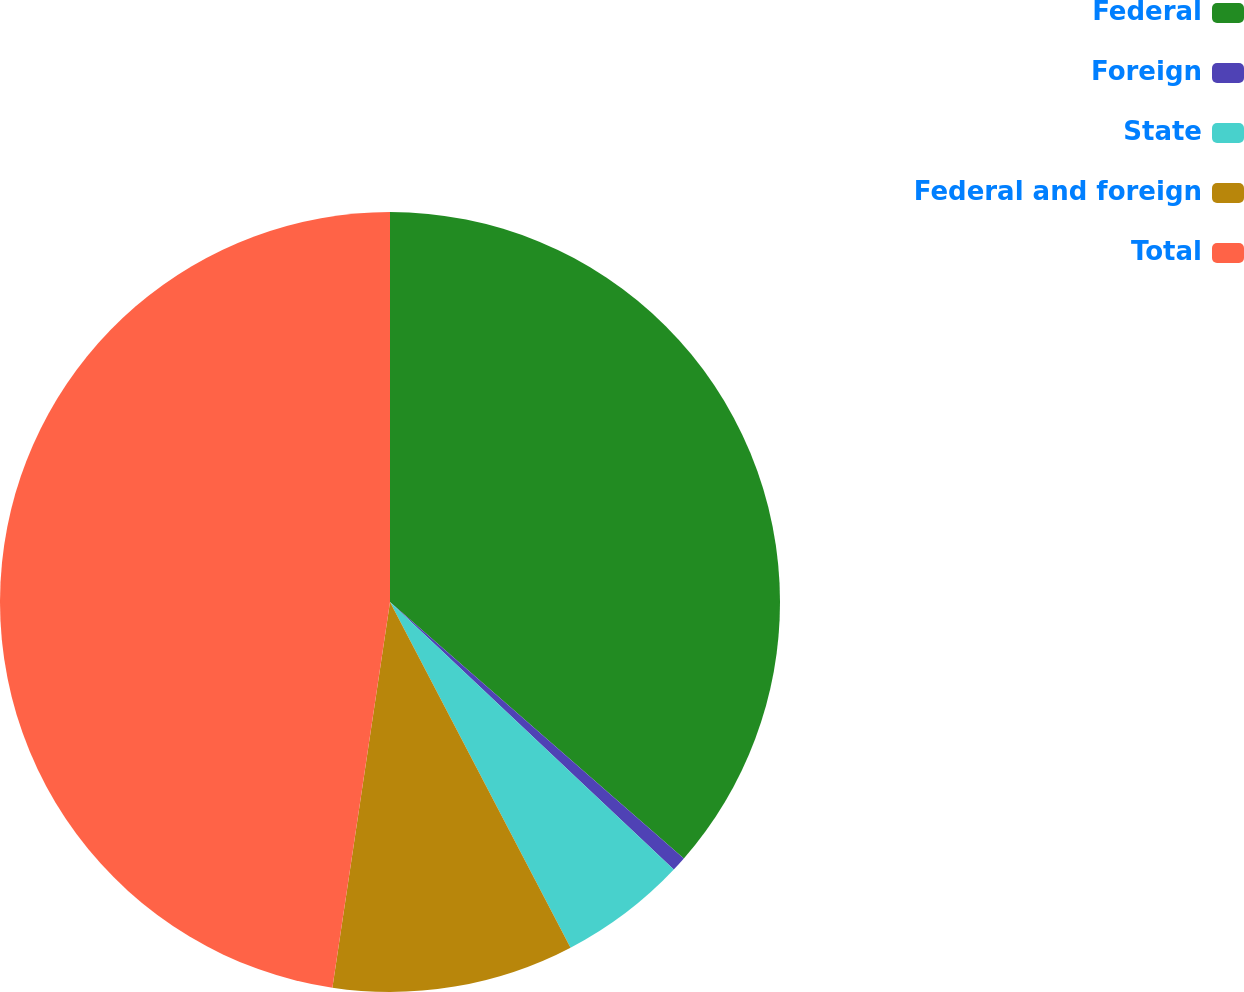<chart> <loc_0><loc_0><loc_500><loc_500><pie_chart><fcel>Federal<fcel>Foreign<fcel>State<fcel>Federal and foreign<fcel>Total<nl><fcel>36.42%<fcel>0.61%<fcel>5.31%<fcel>10.02%<fcel>47.64%<nl></chart> 